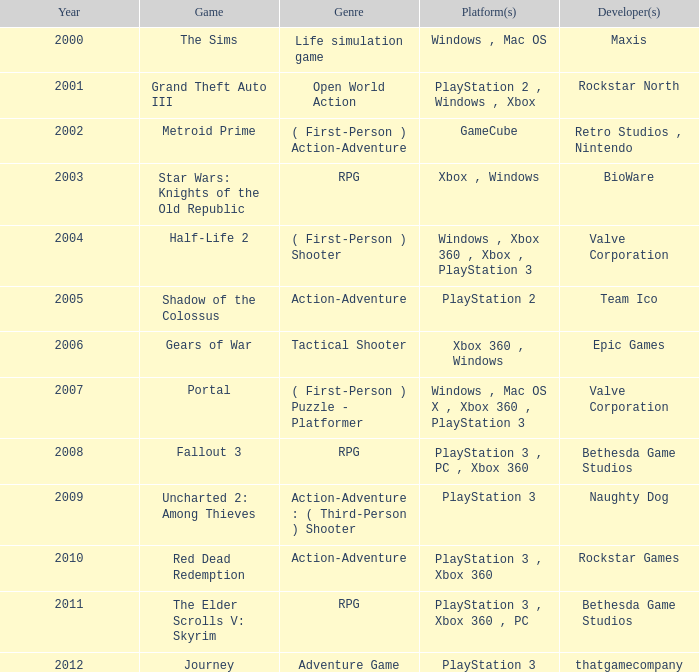What game was in 2011? The Elder Scrolls V: Skyrim. 